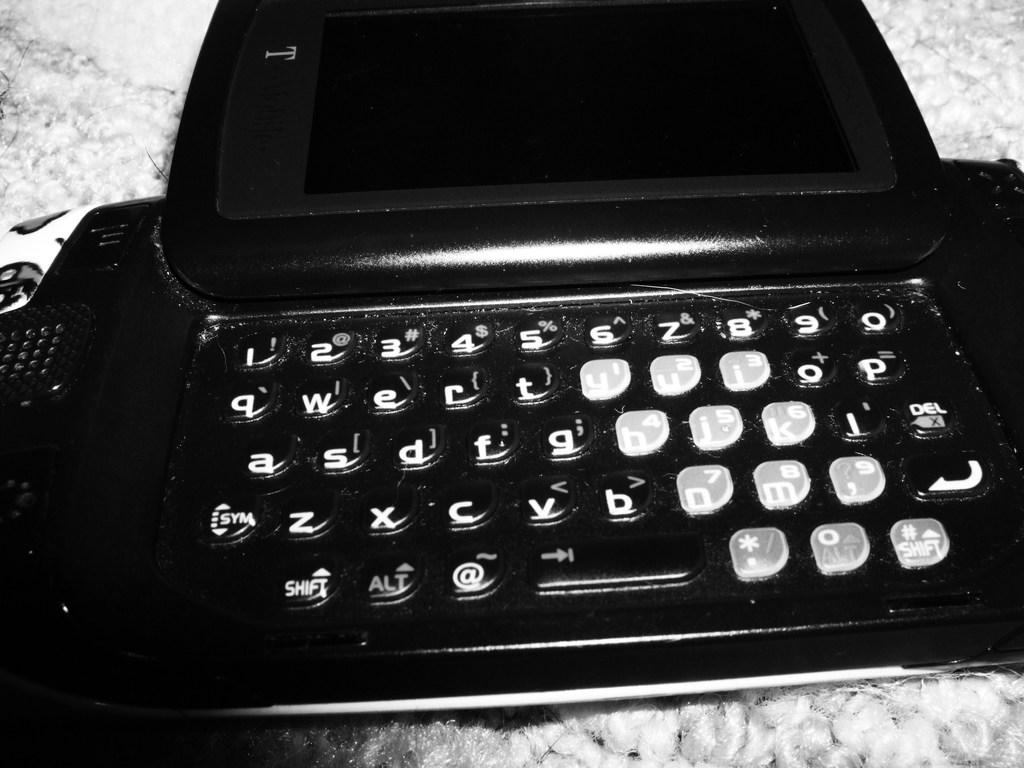Provide a one-sentence caption for the provided image. A old laptop with big keys and one key says sym on it . 